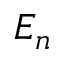<formula> <loc_0><loc_0><loc_500><loc_500>E _ { n }</formula> 